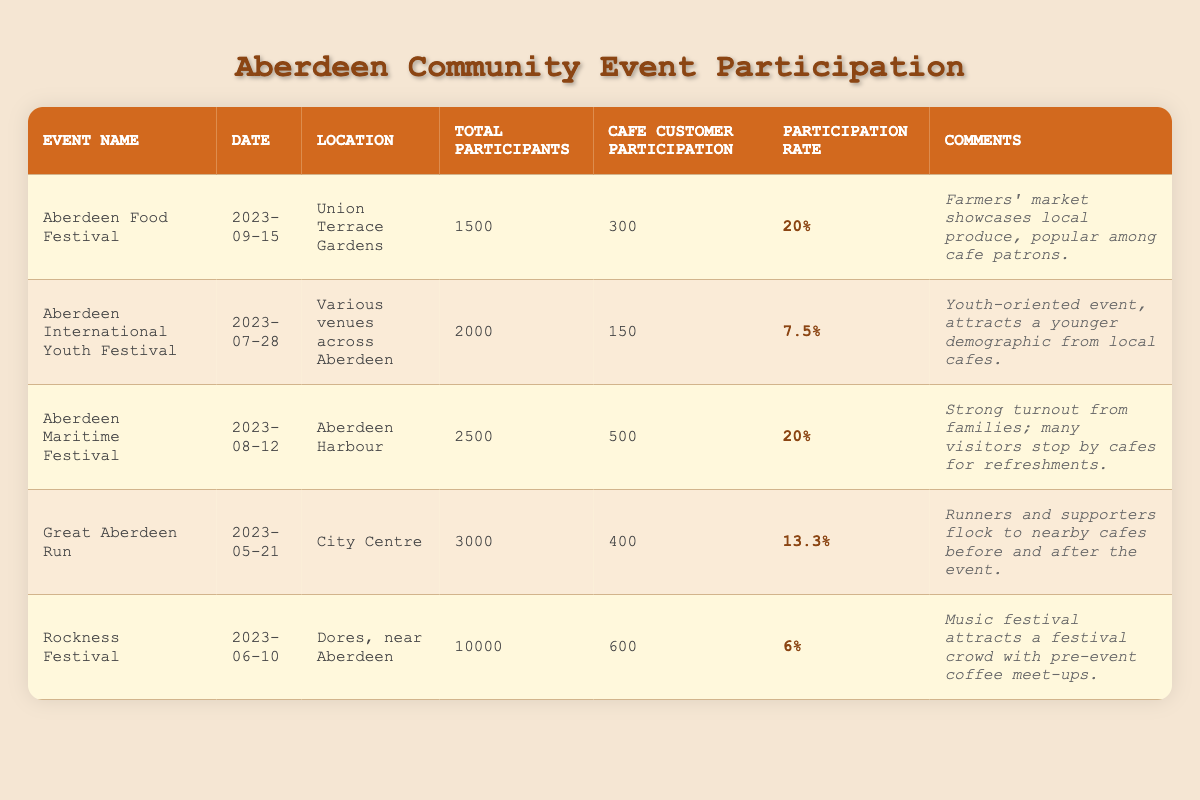What was the participation rate for the Aberdeen Maritime Festival? The participation rate is listed for each event in the table. For the Aberdeen Maritime Festival, the participation rate is stated as 20%.
Answer: 20% How many cafe customers participated in the Great Aberdeen Run? The number of cafe customers participating in the Great Aberdeen Run is directly provided in the table, which states 400 cafe customers took part.
Answer: 400 Which event had the highest total number of participants? Comparing the total participants across all events, the Rockness Festival had the highest total at 10,000 participants.
Answer: Rockness Festival Calculate the average participation rate of all the events listed. The participation rates for the events are 20%, 7.5%, 20%, 13.3%, and 6%. To find the average, sum these values: (20 + 7.5 + 20 + 13.3 + 6) = 66.8, and divide by the number of events (5): 66.8 / 5 = 13.36%.
Answer: 13.36% Was the participation rate for the Rockness Festival lower than that of the Aberdeen Food Festival? The participation rate for Rockness Festival is 6%, while for Aberdeen Food Festival it is 20%. Since 6% is lower than 20%, the statement is true.
Answer: Yes How many cafe customers participated in the Aberdeen Food Festival compared to the Rockness Festival? The cafe customer participation for the Aberdeen Food Festival is 300 and for the Rockness Festival it is 600. Comparing these, 600 is greater than 300.
Answer: 600 (Rockness Festival) Which event attracted the most cafe customers, and how many were there? By looking through the cafe customer participation column, the Aberdeen Maritime Festival attracted the most cafe customers, with a total of 500.
Answer: 500 (Aberdeen Maritime Festival) What is the total number of cafe customers that participated in the events? To find the total, we need to add the cafe customer participation for all the events: 300 + 150 + 500 + 400 + 600 = 2000.
Answer: 2000 Did the majority of cafe customers participate in events held at Union Terrace Gardens? The only event held at Union Terrace Gardens is the Aberdeen Food Festival, which had 300 cafe customers participating. None of the other events had more participants in total or from cafes compared to this venue. Therefore, it's not the majority since total cafe participation across all events is 2000.
Answer: No What do the comments for each event suggest about customer behaviors? The comments generally highlight that many cafe customers are attracted to these events due to their nature, such as family-friendly activities and youth-oriented events, which implies that cafes serve as social hubs during these festivals.
Answer: Events are social hubs 